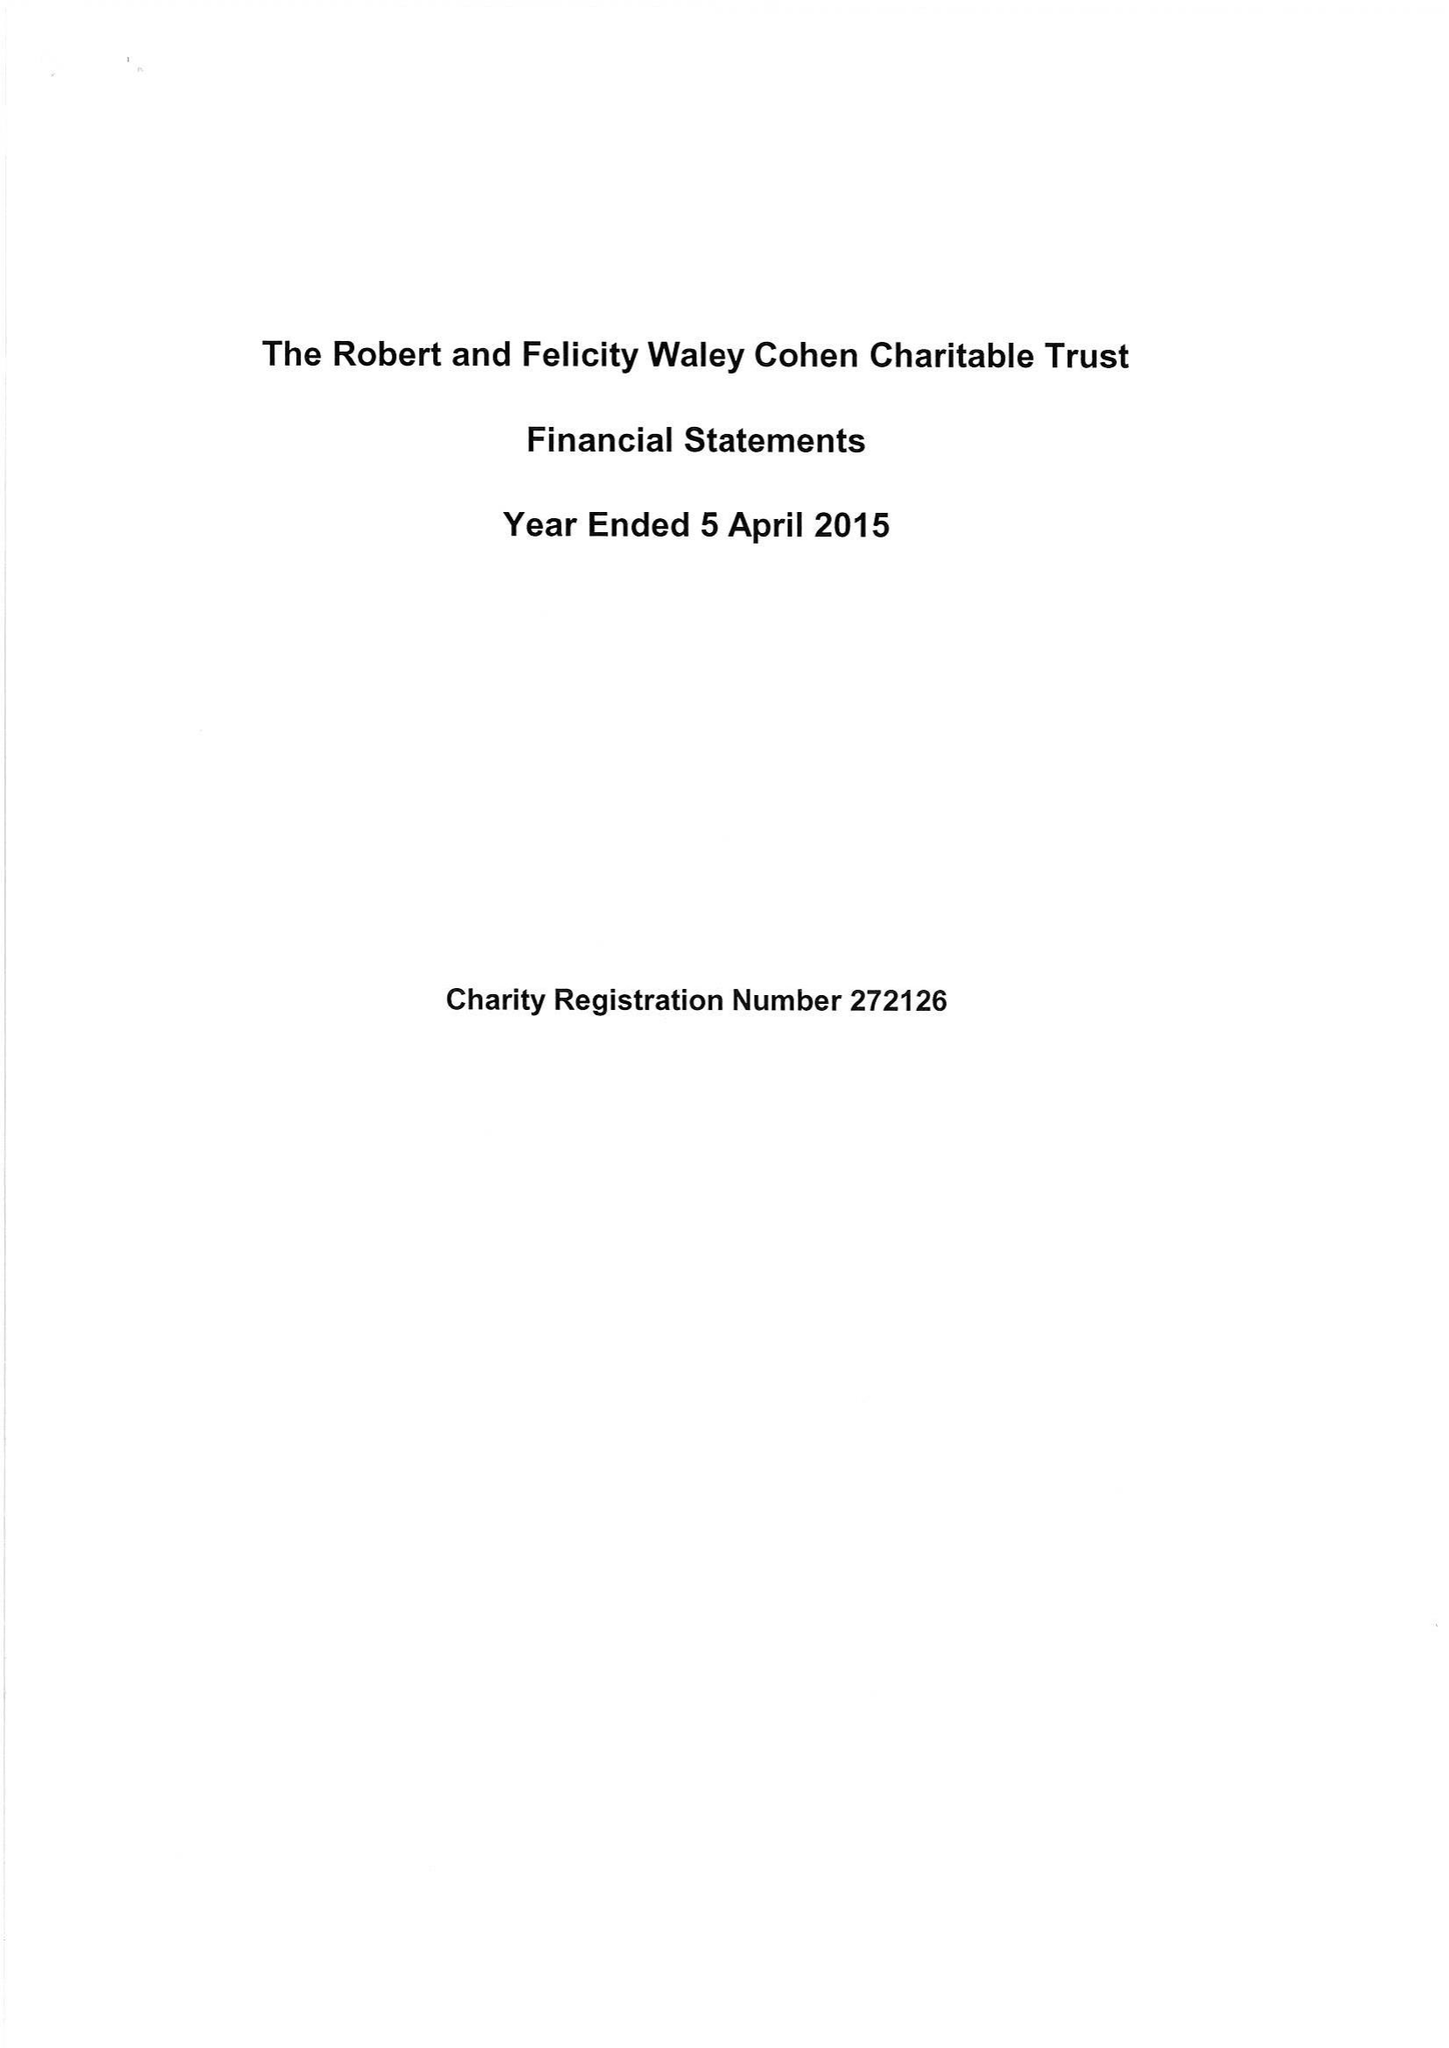What is the value for the income_annually_in_british_pounds?
Answer the question using a single word or phrase. 135684.00 